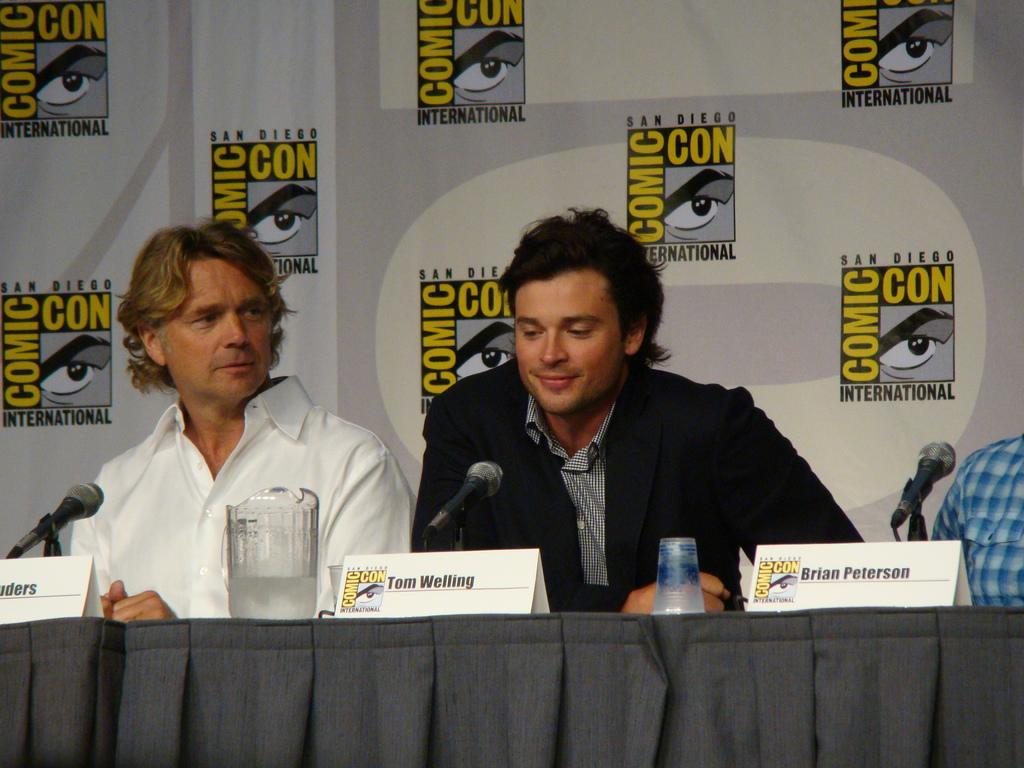In one or two sentences, can you explain what this image depicts? In this image there are three persons sitting, there are name plates, a jug and a glass, there are miles with the miles stands on the table, and in the background there is a board. 